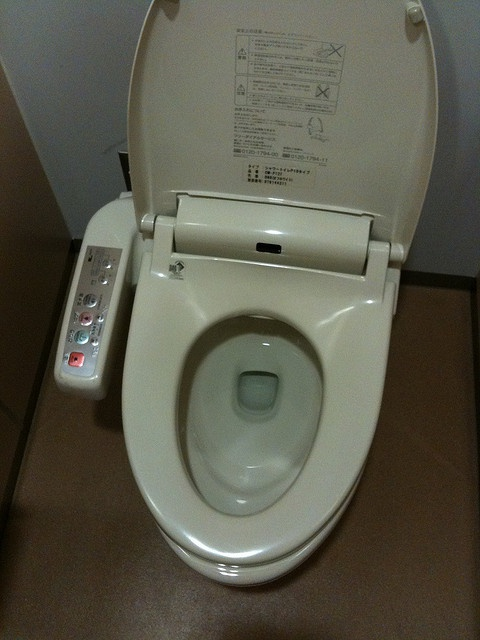Describe the objects in this image and their specific colors. I can see toilet in gray, darkgray, and black tones and remote in gray, darkgray, and black tones in this image. 